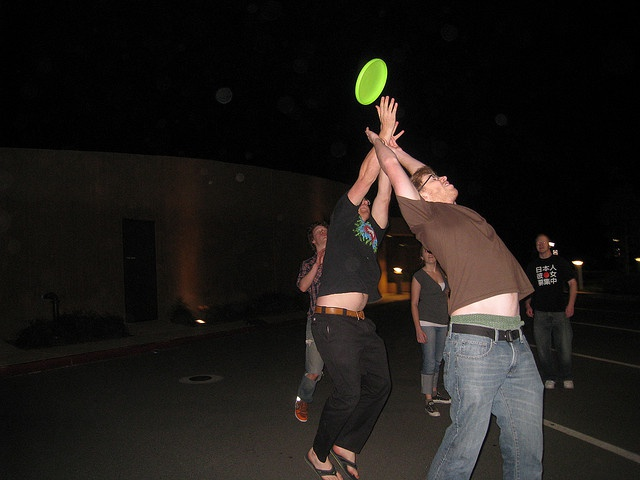Describe the objects in this image and their specific colors. I can see people in black, gray, brown, and lightpink tones, people in black, tan, brown, and salmon tones, people in black, maroon, gray, and brown tones, people in black, gray, brown, and maroon tones, and people in black, gray, maroon, and brown tones in this image. 